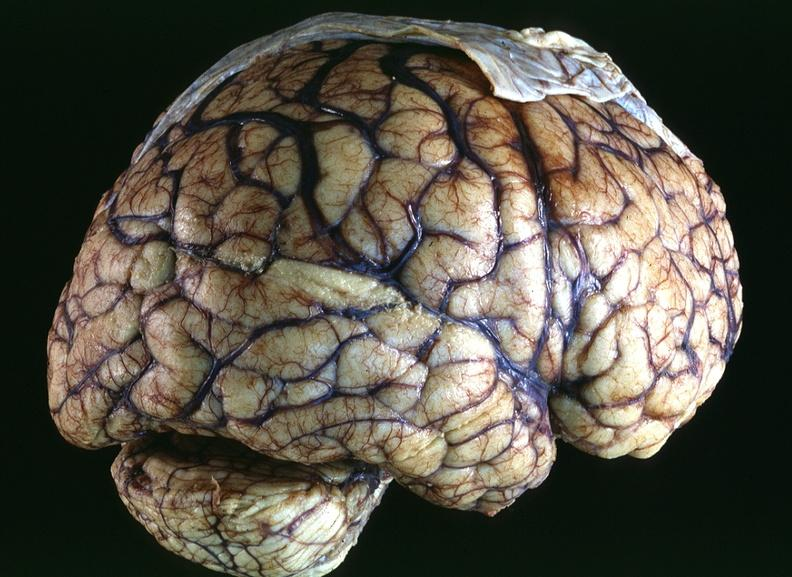s another fiber other frame present?
Answer the question using a single word or phrase. No 